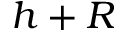<formula> <loc_0><loc_0><loc_500><loc_500>h + R</formula> 